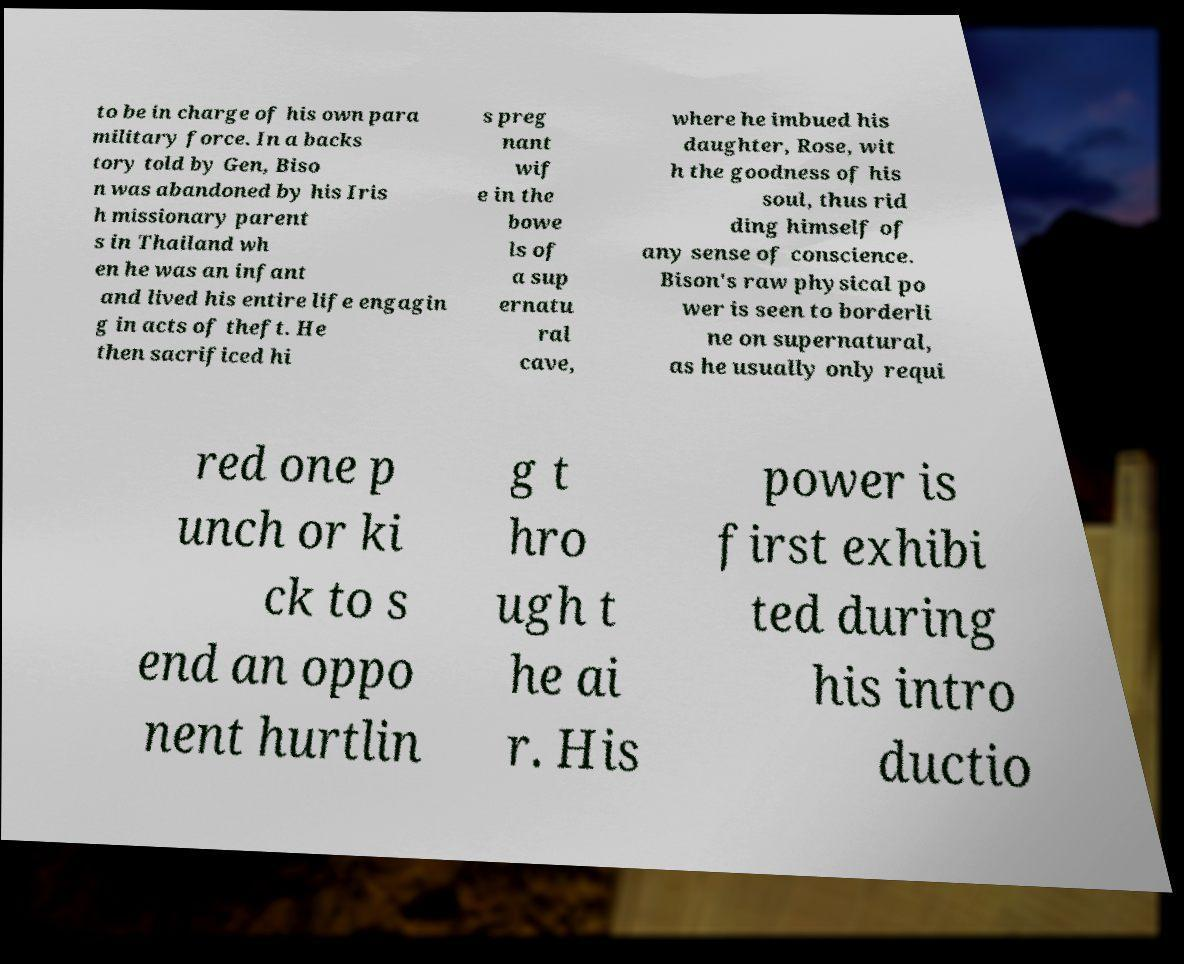I need the written content from this picture converted into text. Can you do that? to be in charge of his own para military force. In a backs tory told by Gen, Biso n was abandoned by his Iris h missionary parent s in Thailand wh en he was an infant and lived his entire life engagin g in acts of theft. He then sacrificed hi s preg nant wif e in the bowe ls of a sup ernatu ral cave, where he imbued his daughter, Rose, wit h the goodness of his soul, thus rid ding himself of any sense of conscience. Bison's raw physical po wer is seen to borderli ne on supernatural, as he usually only requi red one p unch or ki ck to s end an oppo nent hurtlin g t hro ugh t he ai r. His power is first exhibi ted during his intro ductio 